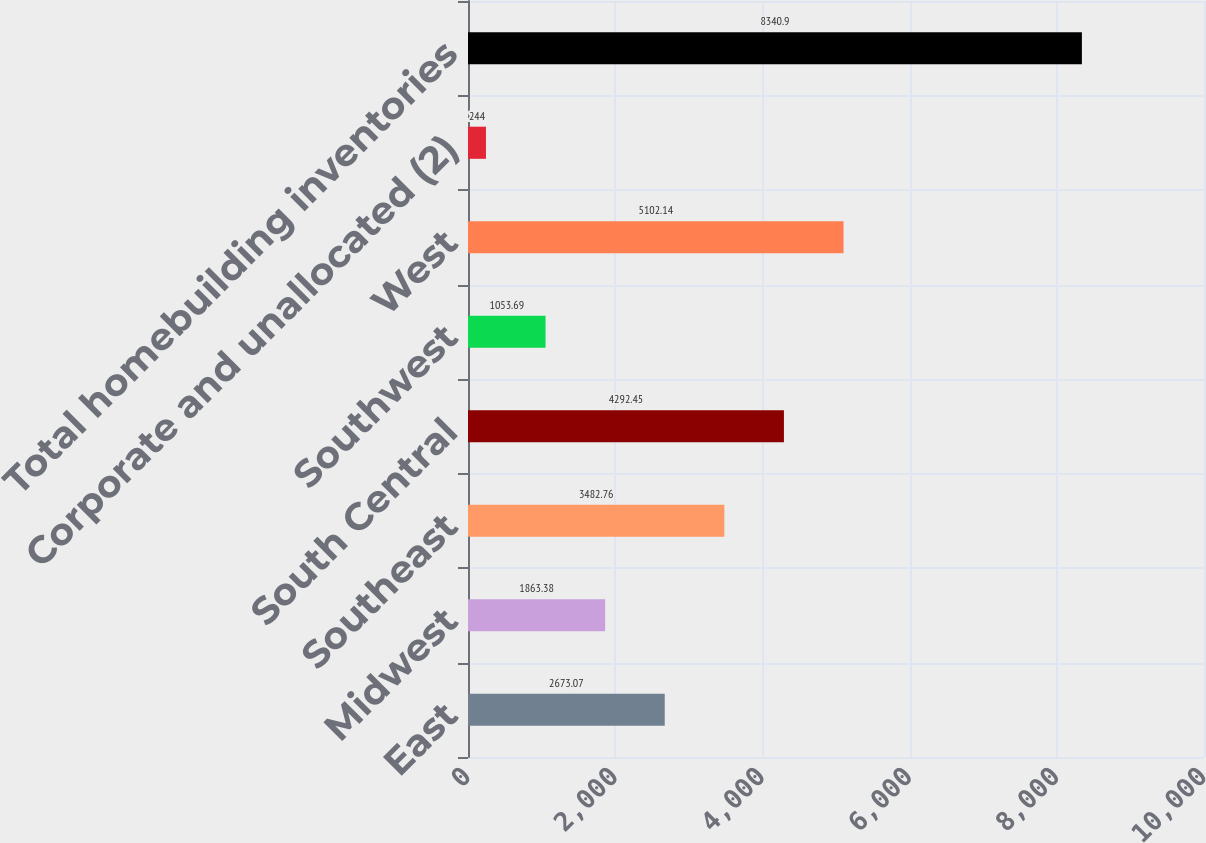Convert chart to OTSL. <chart><loc_0><loc_0><loc_500><loc_500><bar_chart><fcel>East<fcel>Midwest<fcel>Southeast<fcel>South Central<fcel>Southwest<fcel>West<fcel>Corporate and unallocated (2)<fcel>Total homebuilding inventories<nl><fcel>2673.07<fcel>1863.38<fcel>3482.76<fcel>4292.45<fcel>1053.69<fcel>5102.14<fcel>244<fcel>8340.9<nl></chart> 